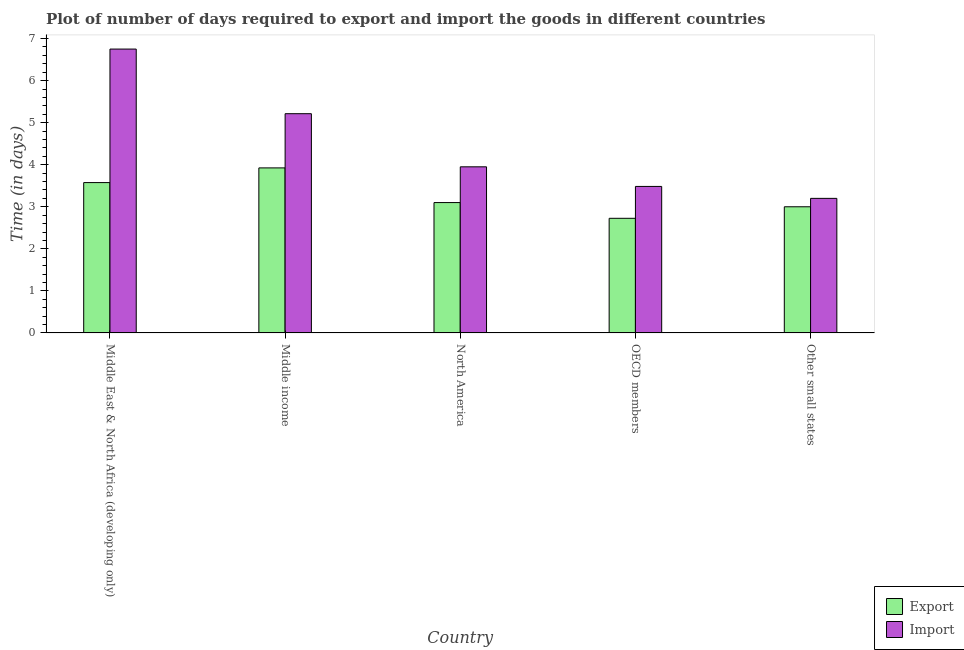How many groups of bars are there?
Offer a very short reply. 5. How many bars are there on the 3rd tick from the right?
Your response must be concise. 2. What is the label of the 4th group of bars from the left?
Your response must be concise. OECD members. In how many cases, is the number of bars for a given country not equal to the number of legend labels?
Make the answer very short. 0. What is the time required to import in Middle income?
Your answer should be compact. 5.21. Across all countries, what is the maximum time required to import?
Ensure brevity in your answer.  6.75. In which country was the time required to export maximum?
Keep it short and to the point. Middle income. In which country was the time required to import minimum?
Make the answer very short. Other small states. What is the total time required to export in the graph?
Your answer should be very brief. 16.33. What is the difference between the time required to import in North America and that in OECD members?
Keep it short and to the point. 0.47. What is the difference between the time required to export in Middle income and the time required to import in North America?
Give a very brief answer. -0.03. What is the average time required to import per country?
Give a very brief answer. 4.52. What is the difference between the time required to import and time required to export in Other small states?
Keep it short and to the point. 0.2. What is the ratio of the time required to import in OECD members to that in Other small states?
Give a very brief answer. 1.09. Is the time required to export in Middle income less than that in OECD members?
Offer a very short reply. No. Is the difference between the time required to import in Middle East & North Africa (developing only) and Middle income greater than the difference between the time required to export in Middle East & North Africa (developing only) and Middle income?
Keep it short and to the point. Yes. What is the difference between the highest and the second highest time required to import?
Keep it short and to the point. 1.54. What is the difference between the highest and the lowest time required to export?
Offer a very short reply. 1.2. Is the sum of the time required to export in Middle East & North Africa (developing only) and Middle income greater than the maximum time required to import across all countries?
Your answer should be very brief. Yes. What does the 1st bar from the left in North America represents?
Keep it short and to the point. Export. What does the 1st bar from the right in Middle income represents?
Make the answer very short. Import. How many countries are there in the graph?
Provide a short and direct response. 5. Are the values on the major ticks of Y-axis written in scientific E-notation?
Your answer should be compact. No. Does the graph contain any zero values?
Provide a succinct answer. No. Does the graph contain grids?
Your answer should be compact. No. What is the title of the graph?
Offer a very short reply. Plot of number of days required to export and import the goods in different countries. What is the label or title of the Y-axis?
Make the answer very short. Time (in days). What is the Time (in days) in Export in Middle East & North Africa (developing only)?
Ensure brevity in your answer.  3.58. What is the Time (in days) of Import in Middle East & North Africa (developing only)?
Give a very brief answer. 6.75. What is the Time (in days) of Export in Middle income?
Ensure brevity in your answer.  3.92. What is the Time (in days) in Import in Middle income?
Offer a very short reply. 5.21. What is the Time (in days) of Import in North America?
Provide a succinct answer. 3.95. What is the Time (in days) in Export in OECD members?
Keep it short and to the point. 2.73. What is the Time (in days) in Import in OECD members?
Make the answer very short. 3.48. Across all countries, what is the maximum Time (in days) in Export?
Provide a short and direct response. 3.92. Across all countries, what is the maximum Time (in days) of Import?
Ensure brevity in your answer.  6.75. Across all countries, what is the minimum Time (in days) of Export?
Your answer should be compact. 2.73. What is the total Time (in days) of Export in the graph?
Offer a terse response. 16.33. What is the total Time (in days) in Import in the graph?
Your response must be concise. 22.6. What is the difference between the Time (in days) of Export in Middle East & North Africa (developing only) and that in Middle income?
Make the answer very short. -0.35. What is the difference between the Time (in days) in Import in Middle East & North Africa (developing only) and that in Middle income?
Provide a succinct answer. 1.54. What is the difference between the Time (in days) in Export in Middle East & North Africa (developing only) and that in North America?
Your answer should be very brief. 0.47. What is the difference between the Time (in days) of Import in Middle East & North Africa (developing only) and that in North America?
Keep it short and to the point. 2.8. What is the difference between the Time (in days) of Export in Middle East & North Africa (developing only) and that in OECD members?
Provide a short and direct response. 0.85. What is the difference between the Time (in days) in Import in Middle East & North Africa (developing only) and that in OECD members?
Give a very brief answer. 3.27. What is the difference between the Time (in days) of Export in Middle East & North Africa (developing only) and that in Other small states?
Keep it short and to the point. 0.57. What is the difference between the Time (in days) in Import in Middle East & North Africa (developing only) and that in Other small states?
Provide a succinct answer. 3.55. What is the difference between the Time (in days) of Export in Middle income and that in North America?
Provide a short and direct response. 0.82. What is the difference between the Time (in days) in Import in Middle income and that in North America?
Your answer should be very brief. 1.26. What is the difference between the Time (in days) in Export in Middle income and that in OECD members?
Keep it short and to the point. 1.2. What is the difference between the Time (in days) in Import in Middle income and that in OECD members?
Provide a short and direct response. 1.73. What is the difference between the Time (in days) in Export in Middle income and that in Other small states?
Your answer should be compact. 0.92. What is the difference between the Time (in days) of Import in Middle income and that in Other small states?
Your answer should be very brief. 2.01. What is the difference between the Time (in days) of Export in North America and that in OECD members?
Your answer should be very brief. 0.37. What is the difference between the Time (in days) in Import in North America and that in OECD members?
Your answer should be compact. 0.47. What is the difference between the Time (in days) of Import in North America and that in Other small states?
Offer a terse response. 0.75. What is the difference between the Time (in days) in Export in OECD members and that in Other small states?
Your response must be concise. -0.27. What is the difference between the Time (in days) in Import in OECD members and that in Other small states?
Ensure brevity in your answer.  0.28. What is the difference between the Time (in days) of Export in Middle East & North Africa (developing only) and the Time (in days) of Import in Middle income?
Ensure brevity in your answer.  -1.64. What is the difference between the Time (in days) in Export in Middle East & North Africa (developing only) and the Time (in days) in Import in North America?
Offer a terse response. -0.38. What is the difference between the Time (in days) in Export in Middle East & North Africa (developing only) and the Time (in days) in Import in OECD members?
Provide a succinct answer. 0.09. What is the difference between the Time (in days) in Export in Middle income and the Time (in days) in Import in North America?
Ensure brevity in your answer.  -0.03. What is the difference between the Time (in days) of Export in Middle income and the Time (in days) of Import in OECD members?
Your answer should be compact. 0.44. What is the difference between the Time (in days) of Export in Middle income and the Time (in days) of Import in Other small states?
Make the answer very short. 0.72. What is the difference between the Time (in days) in Export in North America and the Time (in days) in Import in OECD members?
Provide a succinct answer. -0.38. What is the difference between the Time (in days) of Export in OECD members and the Time (in days) of Import in Other small states?
Your answer should be very brief. -0.47. What is the average Time (in days) in Export per country?
Your response must be concise. 3.27. What is the average Time (in days) of Import per country?
Provide a short and direct response. 4.52. What is the difference between the Time (in days) in Export and Time (in days) in Import in Middle East & North Africa (developing only)?
Make the answer very short. -3.17. What is the difference between the Time (in days) of Export and Time (in days) of Import in Middle income?
Your response must be concise. -1.29. What is the difference between the Time (in days) of Export and Time (in days) of Import in North America?
Give a very brief answer. -0.85. What is the difference between the Time (in days) in Export and Time (in days) in Import in OECD members?
Offer a terse response. -0.76. What is the ratio of the Time (in days) of Export in Middle East & North Africa (developing only) to that in Middle income?
Offer a terse response. 0.91. What is the ratio of the Time (in days) of Import in Middle East & North Africa (developing only) to that in Middle income?
Give a very brief answer. 1.29. What is the ratio of the Time (in days) of Export in Middle East & North Africa (developing only) to that in North America?
Your answer should be compact. 1.15. What is the ratio of the Time (in days) of Import in Middle East & North Africa (developing only) to that in North America?
Provide a short and direct response. 1.71. What is the ratio of the Time (in days) in Export in Middle East & North Africa (developing only) to that in OECD members?
Make the answer very short. 1.31. What is the ratio of the Time (in days) in Import in Middle East & North Africa (developing only) to that in OECD members?
Ensure brevity in your answer.  1.94. What is the ratio of the Time (in days) in Export in Middle East & North Africa (developing only) to that in Other small states?
Your answer should be compact. 1.19. What is the ratio of the Time (in days) in Import in Middle East & North Africa (developing only) to that in Other small states?
Offer a very short reply. 2.11. What is the ratio of the Time (in days) in Export in Middle income to that in North America?
Your response must be concise. 1.27. What is the ratio of the Time (in days) of Import in Middle income to that in North America?
Keep it short and to the point. 1.32. What is the ratio of the Time (in days) in Export in Middle income to that in OECD members?
Your answer should be very brief. 1.44. What is the ratio of the Time (in days) of Import in Middle income to that in OECD members?
Keep it short and to the point. 1.5. What is the ratio of the Time (in days) in Export in Middle income to that in Other small states?
Provide a short and direct response. 1.31. What is the ratio of the Time (in days) of Import in Middle income to that in Other small states?
Provide a succinct answer. 1.63. What is the ratio of the Time (in days) in Export in North America to that in OECD members?
Ensure brevity in your answer.  1.14. What is the ratio of the Time (in days) of Import in North America to that in OECD members?
Ensure brevity in your answer.  1.13. What is the ratio of the Time (in days) of Export in North America to that in Other small states?
Offer a very short reply. 1.03. What is the ratio of the Time (in days) of Import in North America to that in Other small states?
Your answer should be very brief. 1.23. What is the ratio of the Time (in days) of Export in OECD members to that in Other small states?
Ensure brevity in your answer.  0.91. What is the ratio of the Time (in days) of Import in OECD members to that in Other small states?
Your answer should be compact. 1.09. What is the difference between the highest and the second highest Time (in days) in Export?
Offer a terse response. 0.35. What is the difference between the highest and the second highest Time (in days) of Import?
Offer a terse response. 1.54. What is the difference between the highest and the lowest Time (in days) of Export?
Your answer should be very brief. 1.2. What is the difference between the highest and the lowest Time (in days) of Import?
Offer a very short reply. 3.55. 